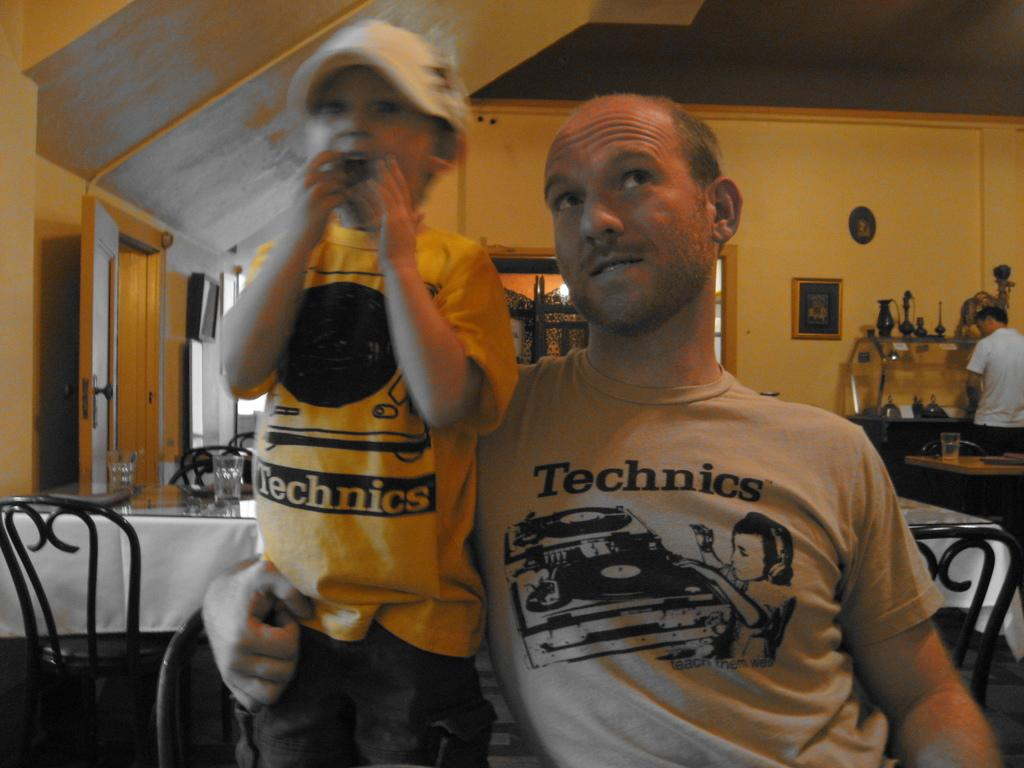What color is the wall in the image? The wall in the image is yellow. What can be seen hanging on the wall? There is a photo frame hanging on the wall in the image. How many people are present in the image? There are three people in the image. What type of furniture is visible in the image? There are chairs and tables in the image. What objects are placed on the table? There are glasses on a table in the image. How many apples are on the table in the image? There are no apples present on the table in the image. What type of button can be seen on the chair in the image? There are no buttons visible on the chairs in the image. 